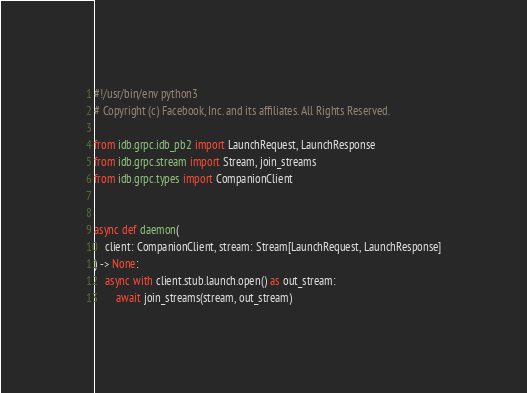<code> <loc_0><loc_0><loc_500><loc_500><_Python_>#!/usr/bin/env python3
# Copyright (c) Facebook, Inc. and its affiliates. All Rights Reserved.

from idb.grpc.idb_pb2 import LaunchRequest, LaunchResponse
from idb.grpc.stream import Stream, join_streams
from idb.grpc.types import CompanionClient


async def daemon(
    client: CompanionClient, stream: Stream[LaunchRequest, LaunchResponse]
) -> None:
    async with client.stub.launch.open() as out_stream:
        await join_streams(stream, out_stream)
</code> 